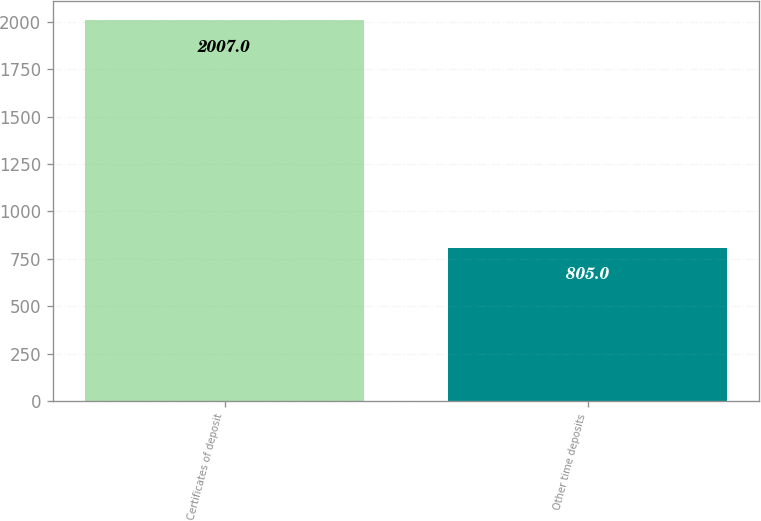Convert chart to OTSL. <chart><loc_0><loc_0><loc_500><loc_500><bar_chart><fcel>Certificates of deposit<fcel>Other time deposits<nl><fcel>2007<fcel>805<nl></chart> 